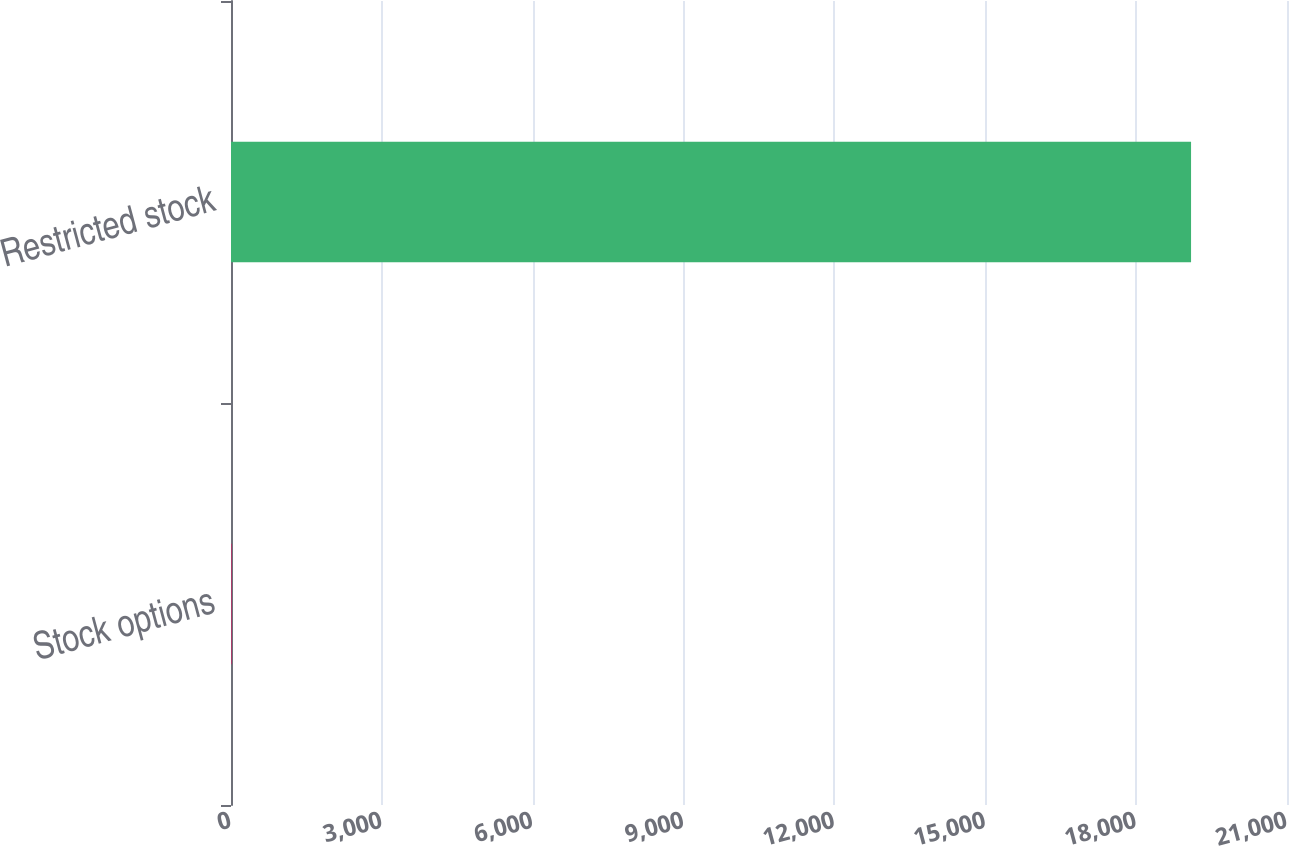<chart> <loc_0><loc_0><loc_500><loc_500><bar_chart><fcel>Stock options<fcel>Restricted stock<nl><fcel>10<fcel>19092<nl></chart> 